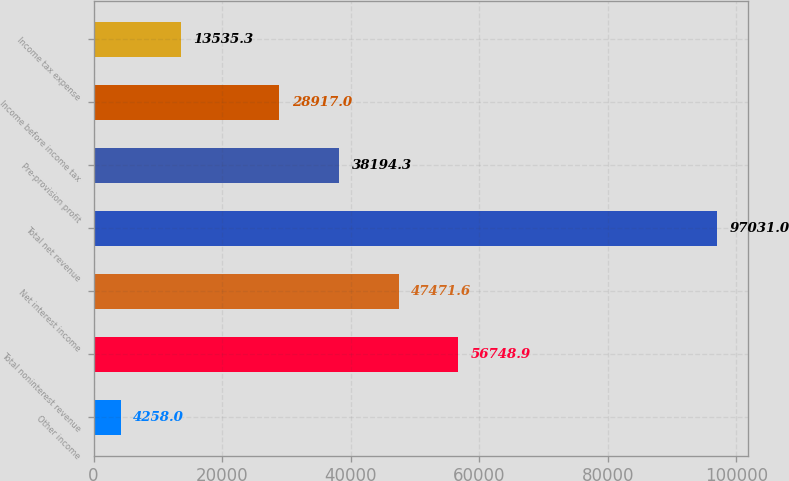Convert chart. <chart><loc_0><loc_0><loc_500><loc_500><bar_chart><fcel>Other income<fcel>Total noninterest revenue<fcel>Net interest income<fcel>Total net revenue<fcel>Pre-provision profit<fcel>Income before income tax<fcel>Income tax expense<nl><fcel>4258<fcel>56748.9<fcel>47471.6<fcel>97031<fcel>38194.3<fcel>28917<fcel>13535.3<nl></chart> 